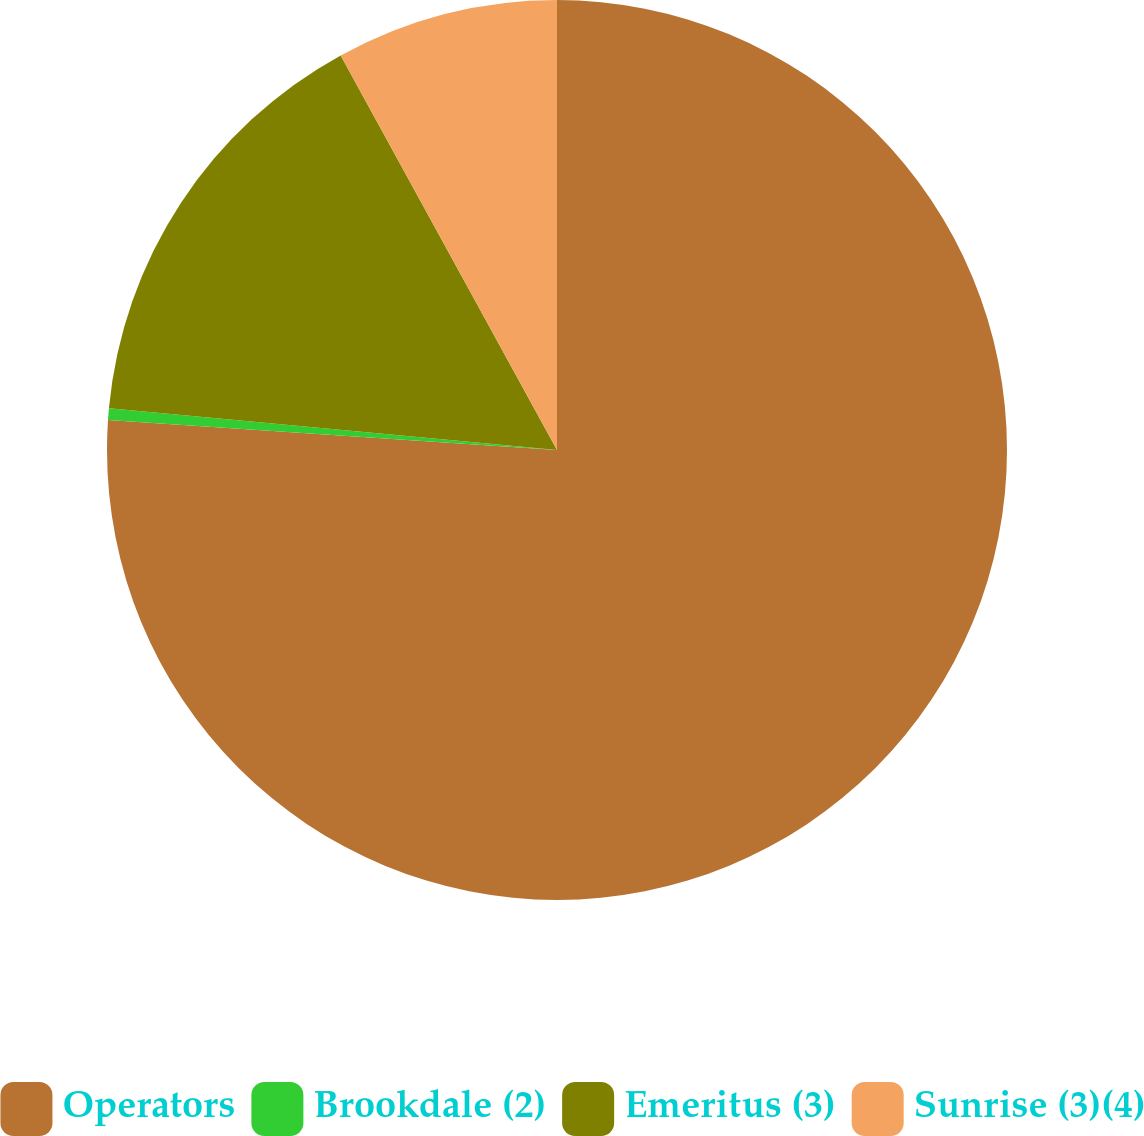Convert chart. <chart><loc_0><loc_0><loc_500><loc_500><pie_chart><fcel>Operators<fcel>Brookdale (2)<fcel>Emeritus (3)<fcel>Sunrise (3)(4)<nl><fcel>76.06%<fcel>0.42%<fcel>15.54%<fcel>7.98%<nl></chart> 